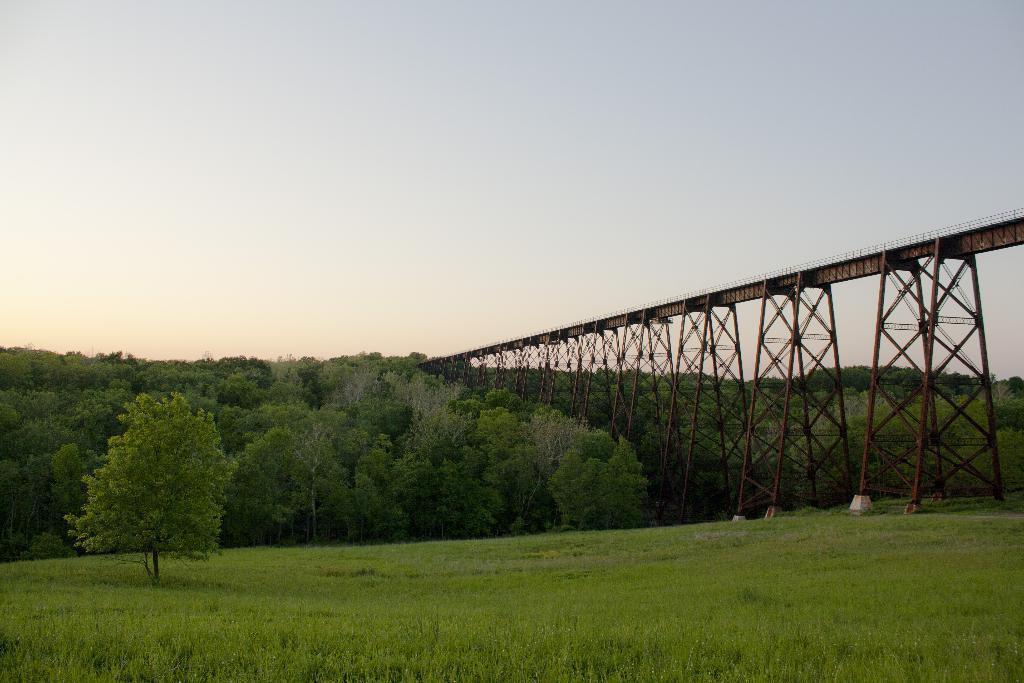Describe this image in one or two sentences. There is a bridge in the right corner and there are trees in the background and the ground is greenery. 